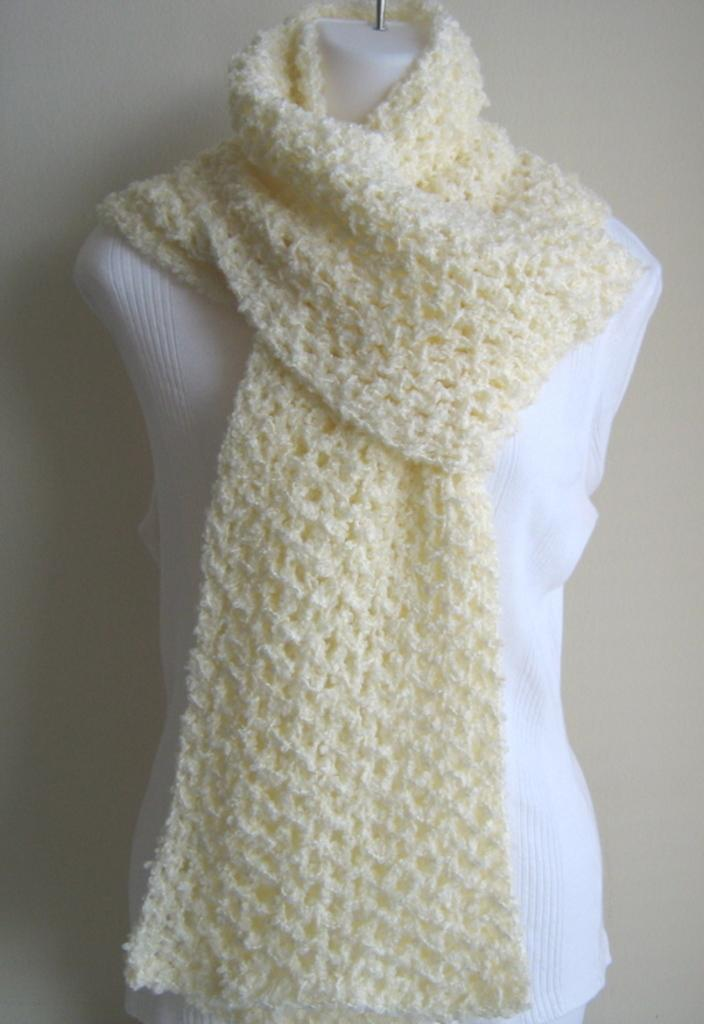What is the main subject in the image? There is a mannequin in the image. What is the mannequin wearing? The mannequin is wearing clothes. What can be seen behind the mannequin? There is a background visible in the image, which includes a surface. What type of cable is connected to the mannequin in the image? There is no cable connected to the mannequin in the image. What kind of pot can be seen on the surface in the background? There is no pot visible in the image; only a surface is mentioned as part of the background. 